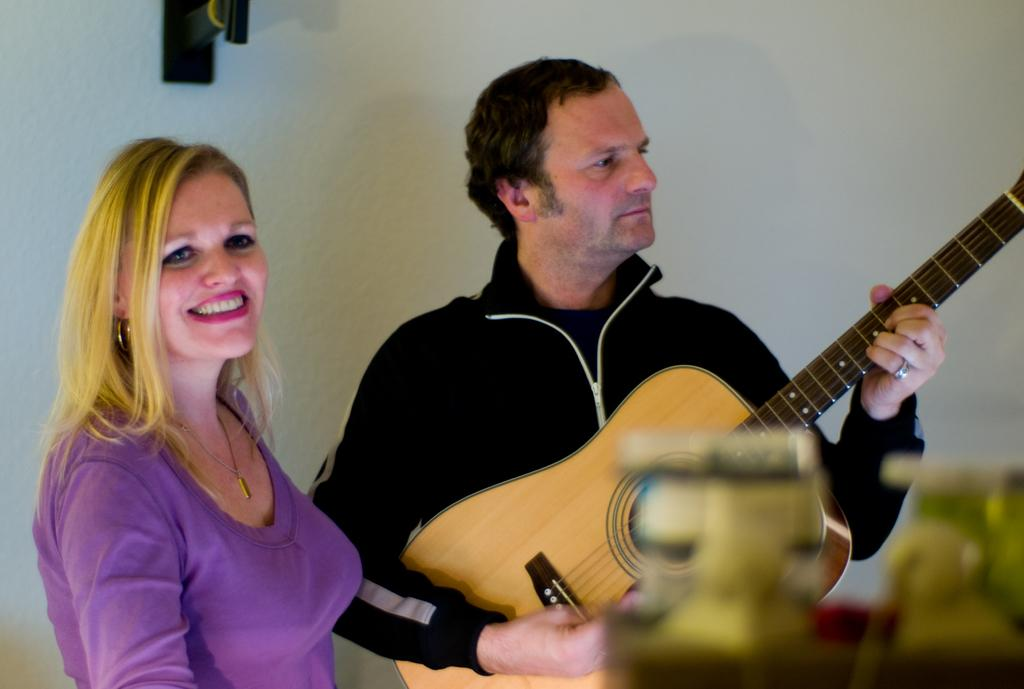What is the man in the image doing? The man is playing a guitar in the image. Who else is present in the image? There is a woman in the image. What is the woman's posture in the image? The woman is standing in the image. How does the woman appear to be feeling in the image? The woman has a smile on her face, suggesting she is happy or enjoying herself. Does the man have a tail in the image? No, the man does not have a tail in the image. Can you see any fangs on the woman in the image? No, there are no fangs visible on the woman in the image. 